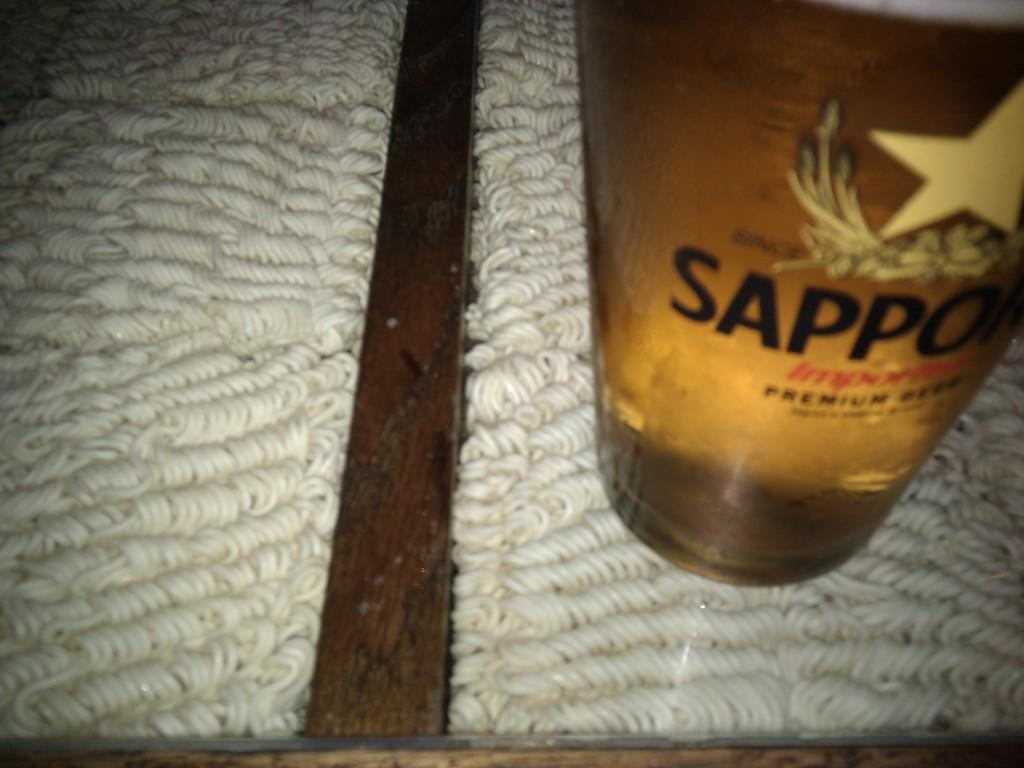<image>
Render a clear and concise summary of the photo. A large glass of beer that reads Sappo. 